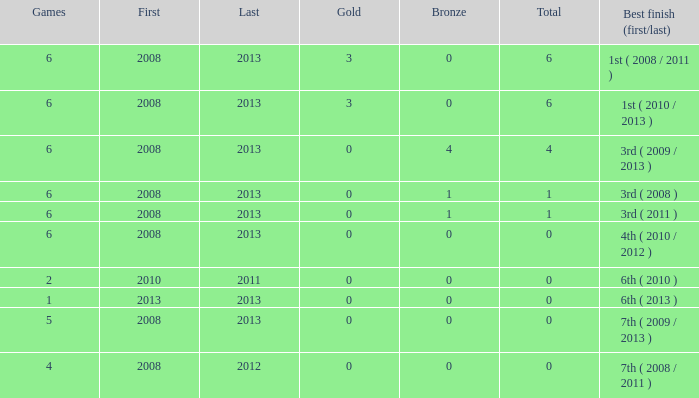What is the minimum number of medals linked with fewer than 6 games and more than 0 golds? None. 